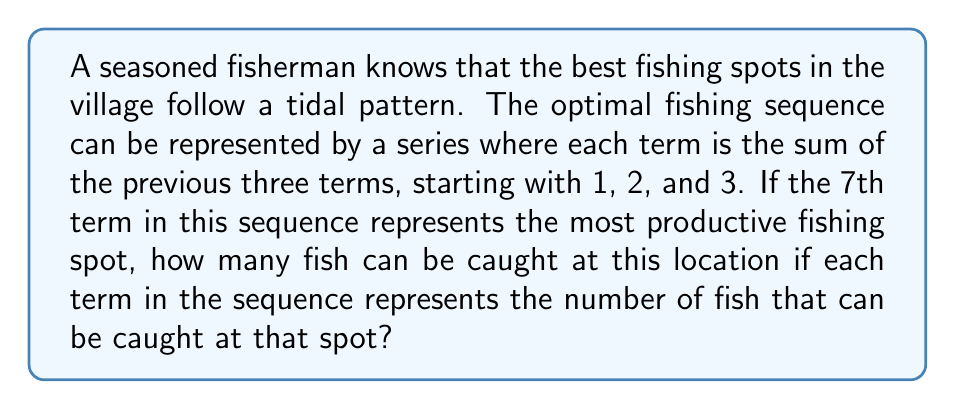Help me with this question. Let's break this down step-by-step:

1) We're dealing with a sequence where each term is the sum of the previous three terms.

2) The sequence starts with 1, 2, and 3.

3) Let's calculate the terms of the sequence:
   
   $a_1 = 1$
   $a_2 = 2$
   $a_3 = 3$
   $a_4 = a_1 + a_2 + a_3 = 1 + 2 + 3 = 6$
   $a_5 = a_2 + a_3 + a_4 = 2 + 3 + 6 = 11$
   $a_6 = a_3 + a_4 + a_5 = 3 + 6 + 11 = 20$
   $a_7 = a_4 + a_5 + a_6 = 6 + 11 + 20 = 37$

4) The question asks for the 7th term, which we've calculated to be 37.

5) Each term represents the number of fish that can be caught at that spot.

Therefore, at the 7th and most productive fishing spot, 37 fish can be caught.
Answer: 37 